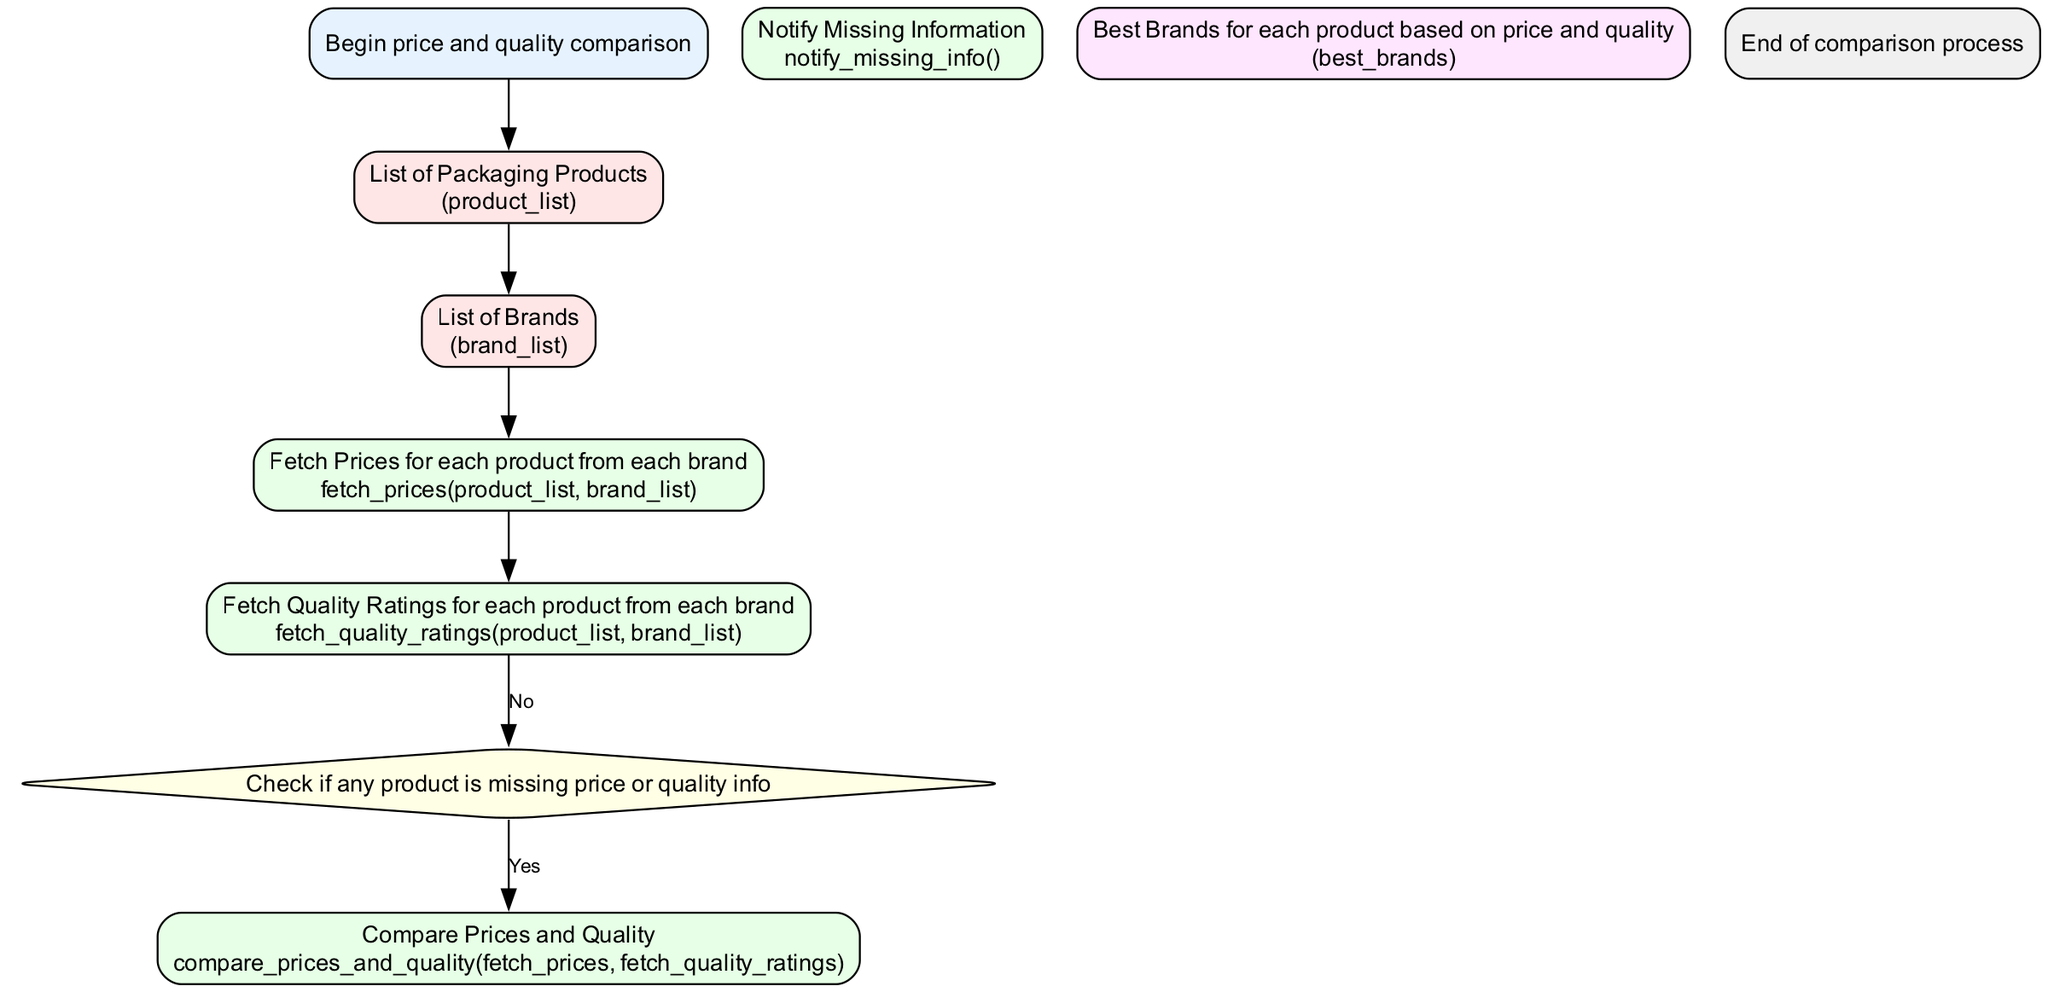what is the title of the diagram? The title of the diagram is specified in the data input under the key "title." It can be found at the beginning of the provided data.
Answer: Steps to Compare Prices and Quality of Packaging Products from Multiple Brands how many total elements are in the diagram? To find the total number of elements, we count the entries in the "elements" list from the data. There are 10 elements listed.
Answer: 10 what is the output of the comparison process? The output is defined in one of the elements as "Best Brands for each product based on price and quality." This is the result of the comparison process.
Answer: Best Brands for each product based on price and quality what happens if there is missing information? If there is missing information, the diagram indicates that it will lead to a process that notifies about missing information, denoted in the process steps of the diagram.
Answer: Notify Missing Information which process fetches quality ratings? The specific process responsible for fetching quality ratings is mentioned as "Fetch Quality Ratings for each product from each brand" in the diagram.
Answer: Fetch Quality Ratings for each product from each brand how do prices and quality get compared? Prices and quality are compared by executing a specific function identified in the process section as "compare_prices_and_quality(fetch_prices, fetch_quality_ratings)."
Answer: compare_prices_and_quality(fetch_prices, fetch_quality_ratings) what is the first action in the flowchart? The first action, as indicated at the beginning of the flowchart, is the "Begin price and quality comparison," which marks the starting point of the process.
Answer: Begin price and quality comparison what is checked after fetching prices and quality ratings? After fetching prices and quality ratings, the flowchart indicates a decision point where it checks if any product is missing price or quality info.
Answer: Check if any product is missing price or quality info how many processes are there in the diagram? To find the number of processes, we review the elements classified as "Process." There are a total of 5 processes identified in the diagram.
Answer: 5 